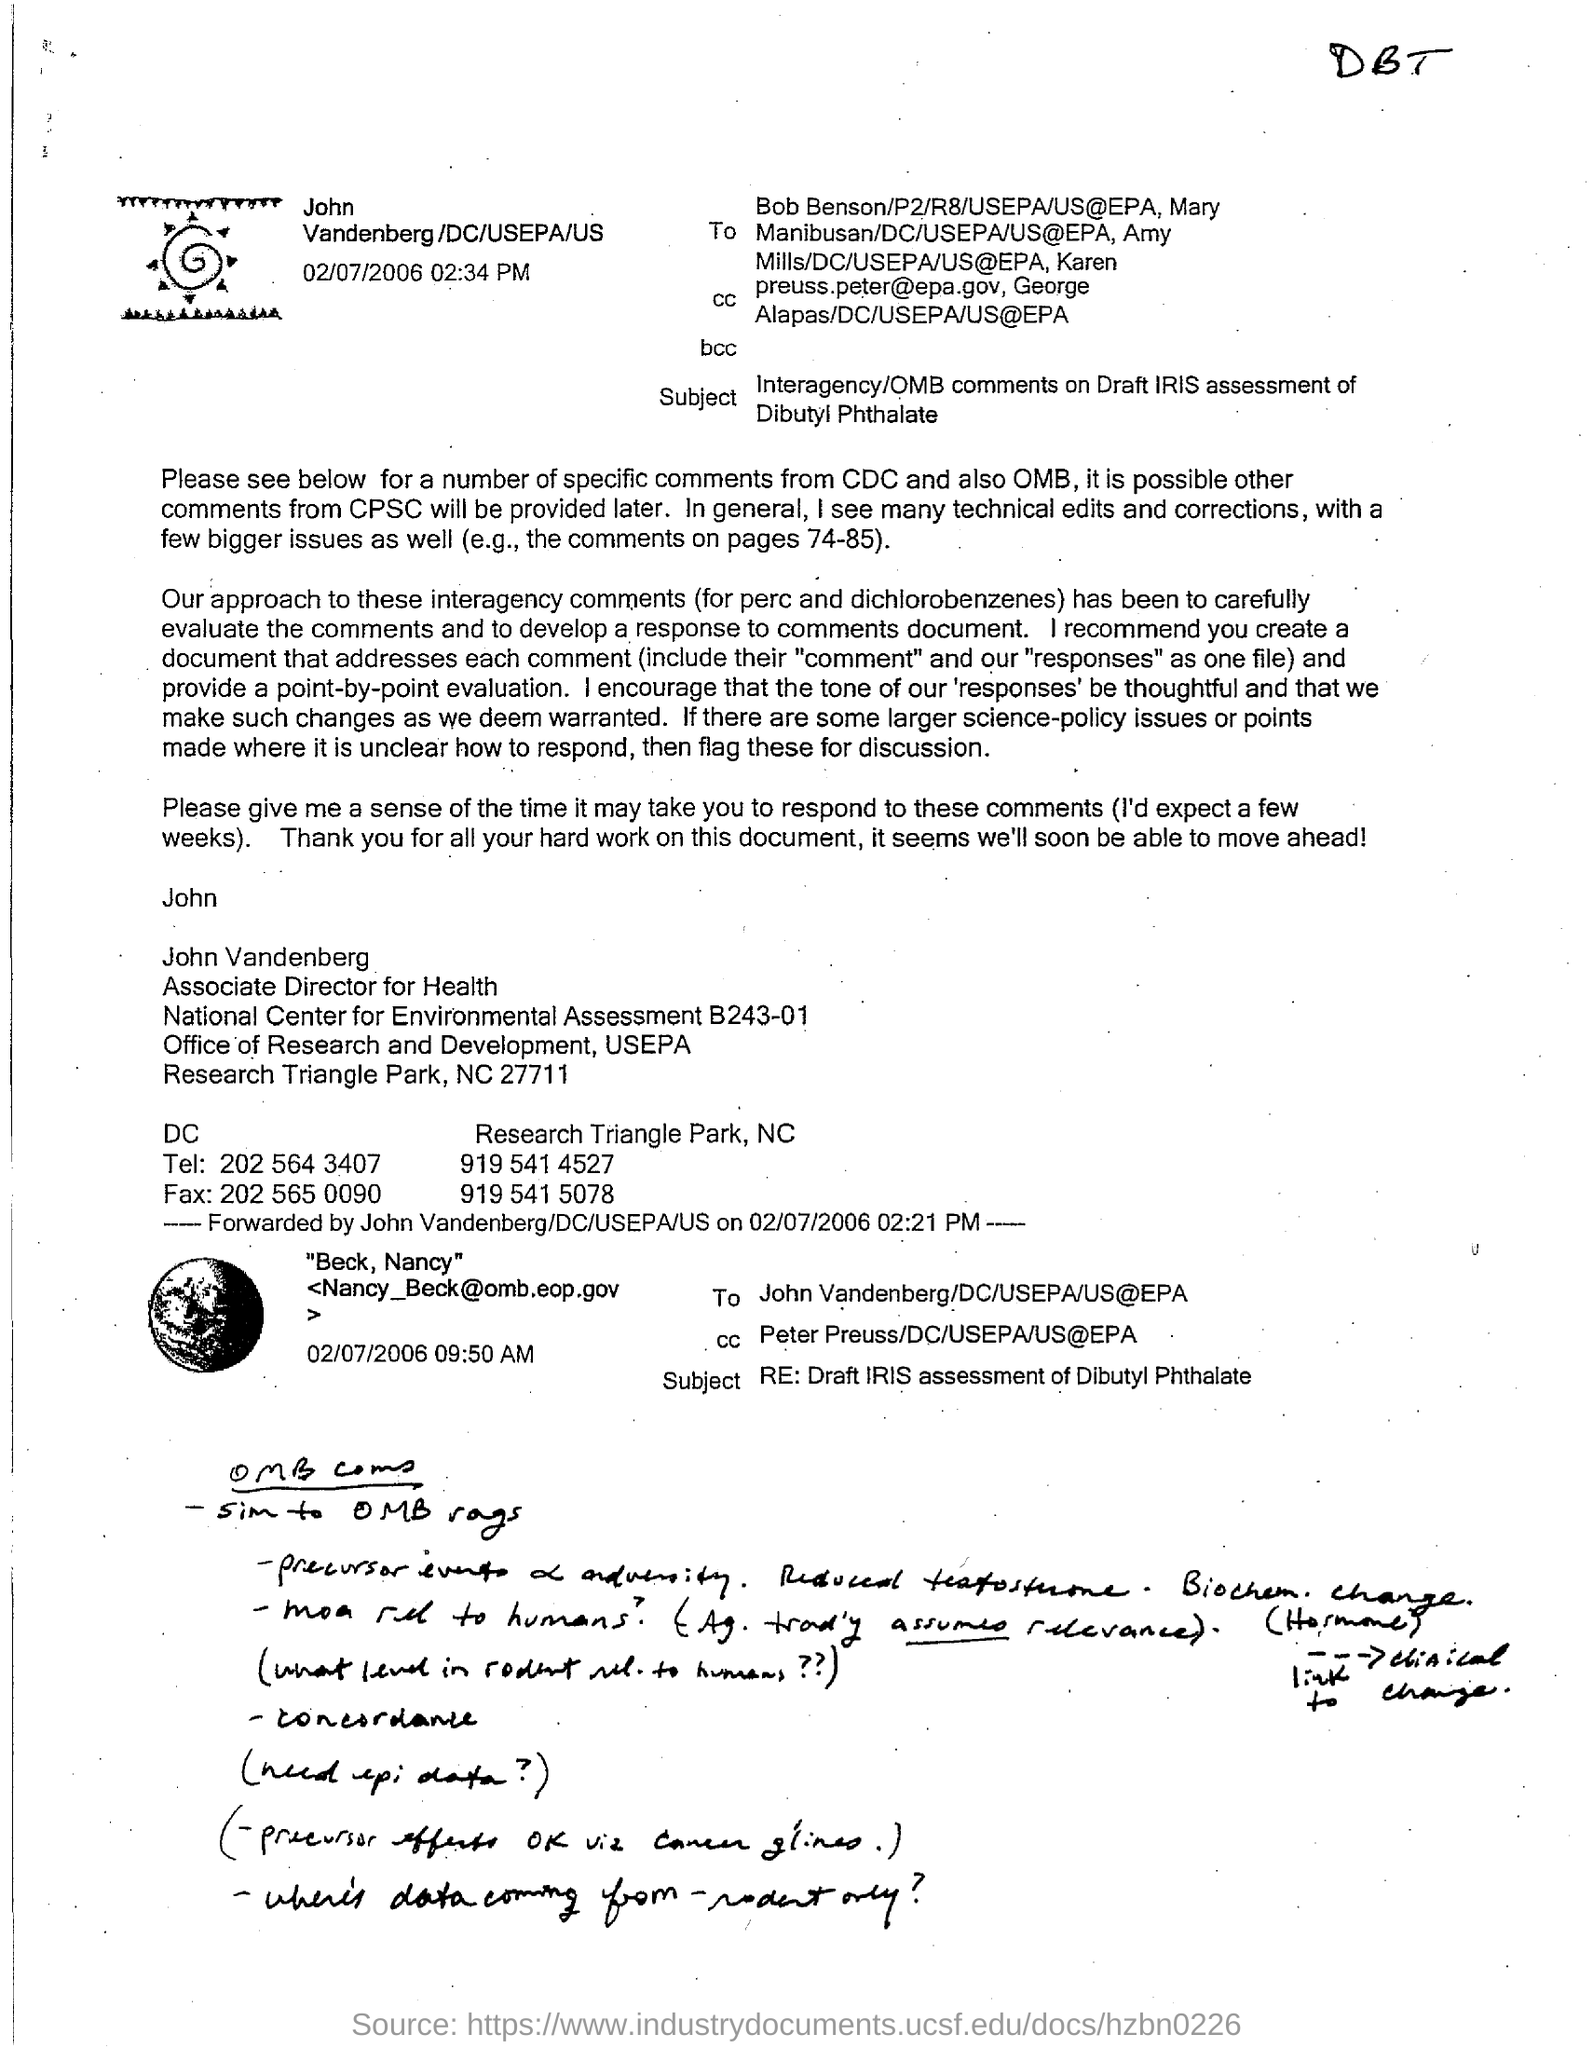Indicate a few pertinent items in this graphic. The Associate Director for Health is named John Vandenberg. 